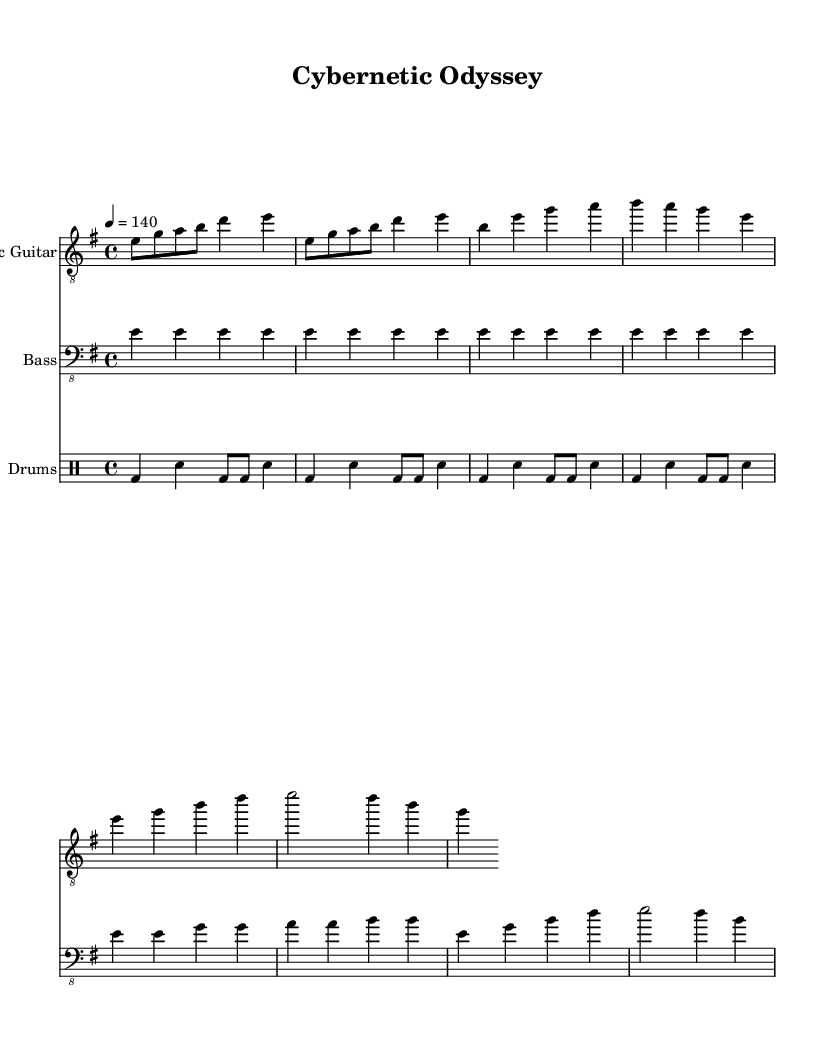What is the key signature of this music? The key signature indicates that the piece is in E minor, which has one sharp (F#). This is determined from the information provided in the `\key` directive.
Answer: E minor What is the time signature of this music? The time signature is revealed by the `\time` directive, which shows that the piece is written in a 4/4 time signature, indicating four beats per measure.
Answer: 4/4 What is the tempo marking for this piece? The tempo is indicated by the `\tempo` directive, which specifies that the piece should be played at a speed of 140 beats per minute.
Answer: 140 What instrument plays the main riff? The electric guitar plays the main riff since it is the first instrument listed under the `\new Staff` directives, which is where the main electric guitar part is notated.
Answer: Electric Guitar How many measures are used in the main riff of the electric guitar? The main riff is marked to repeat twice (`\repeat unfold 2`), where each repeat encompasses one measure; thus, it spans a total of 2 measures.
Answer: 2 measures What characteristic of the bass line is typical of industrial metal? The bass line utilizes a simple rhythmic pattern which is common in industrial metal, often meant to support the heavy guitars rather than being elaborate, as seen in the repeated notes within the verse structure.
Answer: Simplistic rhythmic pattern What is the role of drums in this piece? The drums in this piece serve to provide a driving beat, characterized by a simple and repetitive pattern (`\repeat unfold 4`), which is a hallmark of the industrial metal genre aimed at creating a solid foundation for integration with electric guitars and bass.
Answer: Driving beat 